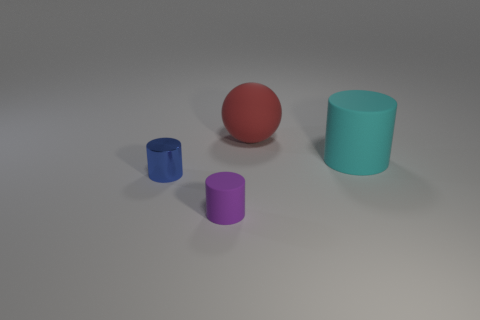Are the objects arranged in any particular pattern? They are not arranged in a specific pattern; they're placed seemingly at random on a flat surface with no discernible order or alignment.  How do the shadows cast by the objects inform us about the light source? The shadows extend to the right of the objects, indicating that the primary light source is to the left. The soft edges of the shadows suggest a diffuse light source, creating a gentle, ambient illumination in the scene. 